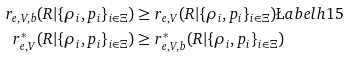<formula> <loc_0><loc_0><loc_500><loc_500>r _ { e , V , b } ( R | \{ \rho _ { i } , p _ { i } \} _ { i \in \Xi } ) & \geq r _ { e , V } ( R | \{ \rho _ { i } , p _ { i } \} _ { i \in \Xi } ) \L a b e l { h 1 5 } \\ r _ { e , V } ^ { * } ( R | \{ \rho _ { i } , p _ { i } \} _ { i \in \Xi } ) & \geq r _ { e , V , b } ^ { * } ( R | \{ \rho _ { i } , p _ { i } \} _ { i \in \Xi } )</formula> 